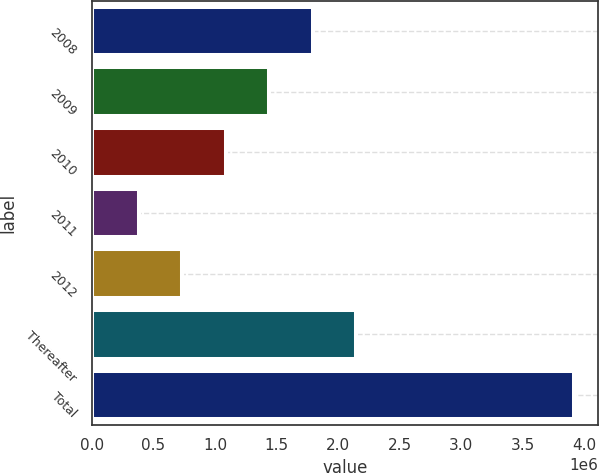Convert chart. <chart><loc_0><loc_0><loc_500><loc_500><bar_chart><fcel>2008<fcel>2009<fcel>2010<fcel>2011<fcel>2012<fcel>Thereafter<fcel>Total<nl><fcel>1.79406e+06<fcel>1.44033e+06<fcel>1.08659e+06<fcel>379124<fcel>732859<fcel>2.1478e+06<fcel>3.91647e+06<nl></chart> 